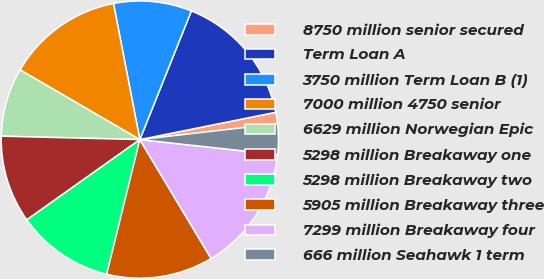Convert chart. <chart><loc_0><loc_0><loc_500><loc_500><pie_chart><fcel>8750 million senior secured<fcel>Term Loan A<fcel>3750 million Term Loan B (1)<fcel>7000 million 4750 senior<fcel>6629 million Norwegian Epic<fcel>5298 million Breakaway one<fcel>5298 million Breakaway two<fcel>5905 million Breakaway three<fcel>7299 million Breakaway four<fcel>666 million Seahawk 1 term<nl><fcel>1.33%<fcel>15.78%<fcel>9.11%<fcel>13.56%<fcel>8.0%<fcel>10.22%<fcel>11.33%<fcel>12.44%<fcel>14.67%<fcel>3.56%<nl></chart> 